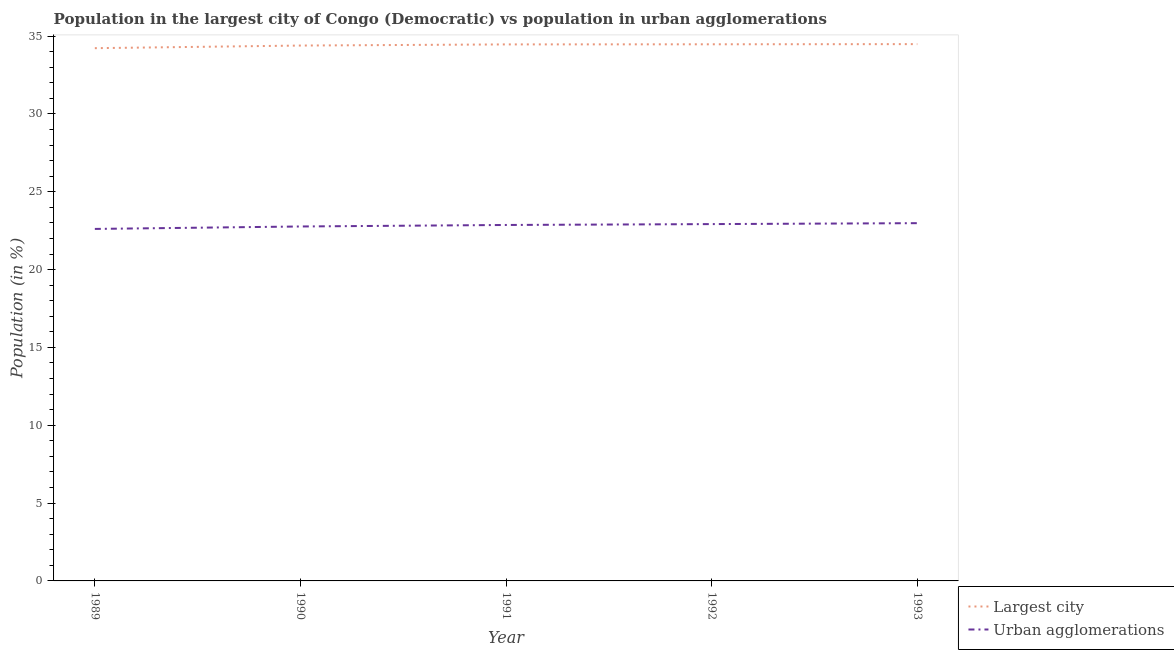Is the number of lines equal to the number of legend labels?
Provide a succinct answer. Yes. What is the population in urban agglomerations in 1989?
Your answer should be very brief. 22.61. Across all years, what is the maximum population in the largest city?
Give a very brief answer. 34.48. Across all years, what is the minimum population in urban agglomerations?
Keep it short and to the point. 22.61. In which year was the population in the largest city minimum?
Make the answer very short. 1989. What is the total population in urban agglomerations in the graph?
Keep it short and to the point. 114.15. What is the difference between the population in urban agglomerations in 1992 and that in 1993?
Give a very brief answer. -0.06. What is the difference between the population in the largest city in 1991 and the population in urban agglomerations in 1990?
Make the answer very short. 11.7. What is the average population in urban agglomerations per year?
Provide a short and direct response. 22.83. In the year 1992, what is the difference between the population in urban agglomerations and population in the largest city?
Keep it short and to the point. -11.55. What is the ratio of the population in urban agglomerations in 1990 to that in 1991?
Ensure brevity in your answer.  1. Is the population in urban agglomerations in 1991 less than that in 1993?
Your answer should be very brief. Yes. Is the difference between the population in urban agglomerations in 1990 and 1991 greater than the difference between the population in the largest city in 1990 and 1991?
Your answer should be very brief. No. What is the difference between the highest and the second highest population in urban agglomerations?
Offer a terse response. 0.06. What is the difference between the highest and the lowest population in urban agglomerations?
Your answer should be very brief. 0.37. Is the sum of the population in the largest city in 1989 and 1990 greater than the maximum population in urban agglomerations across all years?
Your response must be concise. Yes. Is the population in the largest city strictly greater than the population in urban agglomerations over the years?
Make the answer very short. Yes. Is the population in the largest city strictly less than the population in urban agglomerations over the years?
Your response must be concise. No. How many lines are there?
Give a very brief answer. 2. Does the graph contain grids?
Offer a terse response. No. How many legend labels are there?
Provide a succinct answer. 2. How are the legend labels stacked?
Your response must be concise. Vertical. What is the title of the graph?
Make the answer very short. Population in the largest city of Congo (Democratic) vs population in urban agglomerations. Does "Export" appear as one of the legend labels in the graph?
Your answer should be compact. No. What is the Population (in %) in Largest city in 1989?
Your answer should be compact. 34.22. What is the Population (in %) of Urban agglomerations in 1989?
Offer a terse response. 22.61. What is the Population (in %) of Largest city in 1990?
Provide a short and direct response. 34.39. What is the Population (in %) in Urban agglomerations in 1990?
Keep it short and to the point. 22.77. What is the Population (in %) of Largest city in 1991?
Your answer should be very brief. 34.46. What is the Population (in %) in Urban agglomerations in 1991?
Provide a short and direct response. 22.87. What is the Population (in %) in Largest city in 1992?
Give a very brief answer. 34.47. What is the Population (in %) of Urban agglomerations in 1992?
Ensure brevity in your answer.  22.92. What is the Population (in %) in Largest city in 1993?
Your answer should be compact. 34.48. What is the Population (in %) in Urban agglomerations in 1993?
Provide a short and direct response. 22.98. Across all years, what is the maximum Population (in %) of Largest city?
Your answer should be compact. 34.48. Across all years, what is the maximum Population (in %) of Urban agglomerations?
Ensure brevity in your answer.  22.98. Across all years, what is the minimum Population (in %) in Largest city?
Provide a succinct answer. 34.22. Across all years, what is the minimum Population (in %) in Urban agglomerations?
Keep it short and to the point. 22.61. What is the total Population (in %) of Largest city in the graph?
Your response must be concise. 172.03. What is the total Population (in %) in Urban agglomerations in the graph?
Make the answer very short. 114.15. What is the difference between the Population (in %) of Largest city in 1989 and that in 1990?
Ensure brevity in your answer.  -0.17. What is the difference between the Population (in %) of Urban agglomerations in 1989 and that in 1990?
Offer a very short reply. -0.16. What is the difference between the Population (in %) in Largest city in 1989 and that in 1991?
Your answer should be compact. -0.24. What is the difference between the Population (in %) in Urban agglomerations in 1989 and that in 1991?
Your answer should be compact. -0.25. What is the difference between the Population (in %) of Largest city in 1989 and that in 1992?
Your response must be concise. -0.25. What is the difference between the Population (in %) of Urban agglomerations in 1989 and that in 1992?
Your answer should be very brief. -0.31. What is the difference between the Population (in %) in Largest city in 1989 and that in 1993?
Give a very brief answer. -0.26. What is the difference between the Population (in %) in Urban agglomerations in 1989 and that in 1993?
Provide a succinct answer. -0.37. What is the difference between the Population (in %) in Largest city in 1990 and that in 1991?
Provide a short and direct response. -0.07. What is the difference between the Population (in %) of Urban agglomerations in 1990 and that in 1991?
Provide a succinct answer. -0.1. What is the difference between the Population (in %) of Largest city in 1990 and that in 1992?
Offer a very short reply. -0.08. What is the difference between the Population (in %) of Urban agglomerations in 1990 and that in 1992?
Ensure brevity in your answer.  -0.15. What is the difference between the Population (in %) in Largest city in 1990 and that in 1993?
Offer a very short reply. -0.09. What is the difference between the Population (in %) of Urban agglomerations in 1990 and that in 1993?
Keep it short and to the point. -0.21. What is the difference between the Population (in %) of Largest city in 1991 and that in 1992?
Your answer should be very brief. -0.01. What is the difference between the Population (in %) of Urban agglomerations in 1991 and that in 1992?
Offer a terse response. -0.06. What is the difference between the Population (in %) in Largest city in 1991 and that in 1993?
Offer a very short reply. -0.02. What is the difference between the Population (in %) of Urban agglomerations in 1991 and that in 1993?
Make the answer very short. -0.12. What is the difference between the Population (in %) of Largest city in 1992 and that in 1993?
Your response must be concise. -0.01. What is the difference between the Population (in %) in Urban agglomerations in 1992 and that in 1993?
Provide a succinct answer. -0.06. What is the difference between the Population (in %) of Largest city in 1989 and the Population (in %) of Urban agglomerations in 1990?
Provide a succinct answer. 11.45. What is the difference between the Population (in %) in Largest city in 1989 and the Population (in %) in Urban agglomerations in 1991?
Your response must be concise. 11.36. What is the difference between the Population (in %) of Largest city in 1989 and the Population (in %) of Urban agglomerations in 1992?
Provide a short and direct response. 11.3. What is the difference between the Population (in %) of Largest city in 1989 and the Population (in %) of Urban agglomerations in 1993?
Your answer should be compact. 11.24. What is the difference between the Population (in %) in Largest city in 1990 and the Population (in %) in Urban agglomerations in 1991?
Your answer should be compact. 11.53. What is the difference between the Population (in %) of Largest city in 1990 and the Population (in %) of Urban agglomerations in 1992?
Ensure brevity in your answer.  11.47. What is the difference between the Population (in %) of Largest city in 1990 and the Population (in %) of Urban agglomerations in 1993?
Keep it short and to the point. 11.41. What is the difference between the Population (in %) in Largest city in 1991 and the Population (in %) in Urban agglomerations in 1992?
Your answer should be compact. 11.54. What is the difference between the Population (in %) of Largest city in 1991 and the Population (in %) of Urban agglomerations in 1993?
Provide a short and direct response. 11.48. What is the difference between the Population (in %) of Largest city in 1992 and the Population (in %) of Urban agglomerations in 1993?
Your answer should be compact. 11.49. What is the average Population (in %) of Largest city per year?
Your answer should be compact. 34.41. What is the average Population (in %) in Urban agglomerations per year?
Your answer should be very brief. 22.83. In the year 1989, what is the difference between the Population (in %) in Largest city and Population (in %) in Urban agglomerations?
Offer a very short reply. 11.61. In the year 1990, what is the difference between the Population (in %) of Largest city and Population (in %) of Urban agglomerations?
Provide a succinct answer. 11.62. In the year 1991, what is the difference between the Population (in %) in Largest city and Population (in %) in Urban agglomerations?
Keep it short and to the point. 11.6. In the year 1992, what is the difference between the Population (in %) of Largest city and Population (in %) of Urban agglomerations?
Offer a terse response. 11.55. In the year 1993, what is the difference between the Population (in %) of Largest city and Population (in %) of Urban agglomerations?
Give a very brief answer. 11.5. What is the ratio of the Population (in %) of Largest city in 1989 to that in 1990?
Provide a short and direct response. 1. What is the ratio of the Population (in %) of Urban agglomerations in 1989 to that in 1990?
Your answer should be very brief. 0.99. What is the ratio of the Population (in %) of Urban agglomerations in 1989 to that in 1991?
Make the answer very short. 0.99. What is the ratio of the Population (in %) in Largest city in 1989 to that in 1992?
Your answer should be very brief. 0.99. What is the ratio of the Population (in %) of Urban agglomerations in 1989 to that in 1992?
Provide a succinct answer. 0.99. What is the ratio of the Population (in %) in Largest city in 1989 to that in 1993?
Ensure brevity in your answer.  0.99. What is the ratio of the Population (in %) of Urban agglomerations in 1989 to that in 1993?
Keep it short and to the point. 0.98. What is the ratio of the Population (in %) in Largest city in 1990 to that in 1992?
Provide a short and direct response. 1. What is the ratio of the Population (in %) in Largest city in 1990 to that in 1993?
Your response must be concise. 1. What is the ratio of the Population (in %) of Urban agglomerations in 1990 to that in 1993?
Provide a succinct answer. 0.99. What is the ratio of the Population (in %) in Urban agglomerations in 1991 to that in 1993?
Provide a short and direct response. 0.99. What is the ratio of the Population (in %) in Largest city in 1992 to that in 1993?
Your response must be concise. 1. What is the ratio of the Population (in %) of Urban agglomerations in 1992 to that in 1993?
Your answer should be very brief. 1. What is the difference between the highest and the second highest Population (in %) in Largest city?
Give a very brief answer. 0.01. What is the difference between the highest and the second highest Population (in %) in Urban agglomerations?
Your answer should be compact. 0.06. What is the difference between the highest and the lowest Population (in %) in Largest city?
Offer a terse response. 0.26. What is the difference between the highest and the lowest Population (in %) of Urban agglomerations?
Give a very brief answer. 0.37. 